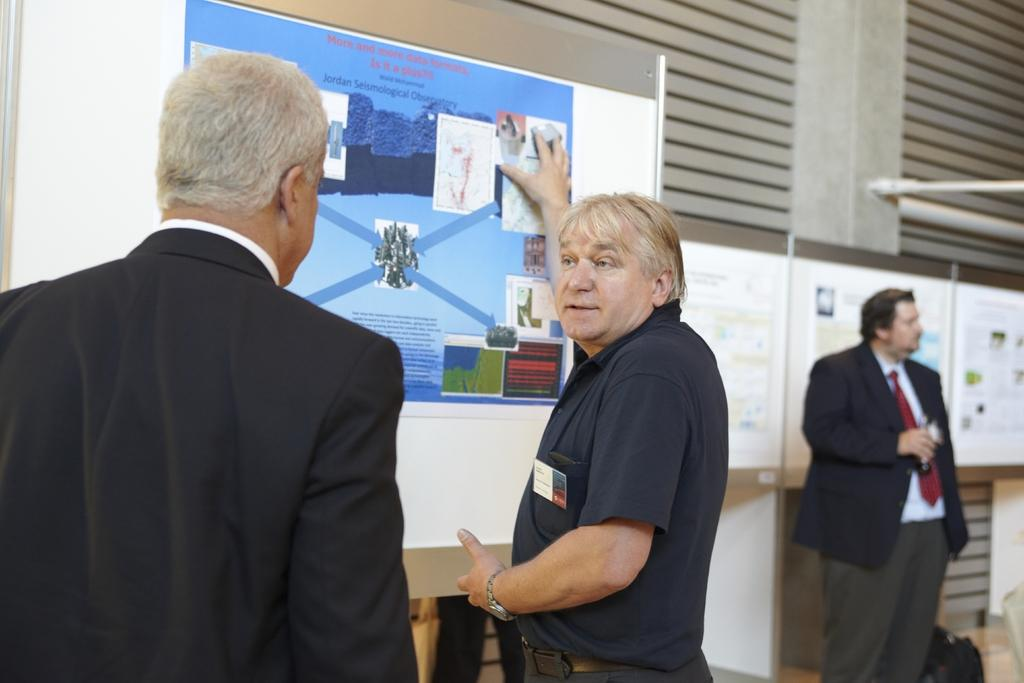What can be seen in the foreground of the image? There are men in the foreground of the image. What is in front of the men in the image? There is a poster in front of the men. What is visible in the background of the image? There is a person, a bag, a pillar, and posters in the background of the image. What type of bun is being served on the side of the image? There is no bun present in the image. How many days are depicted in the image? The image does not depict any days or weeks; it is a still image. 